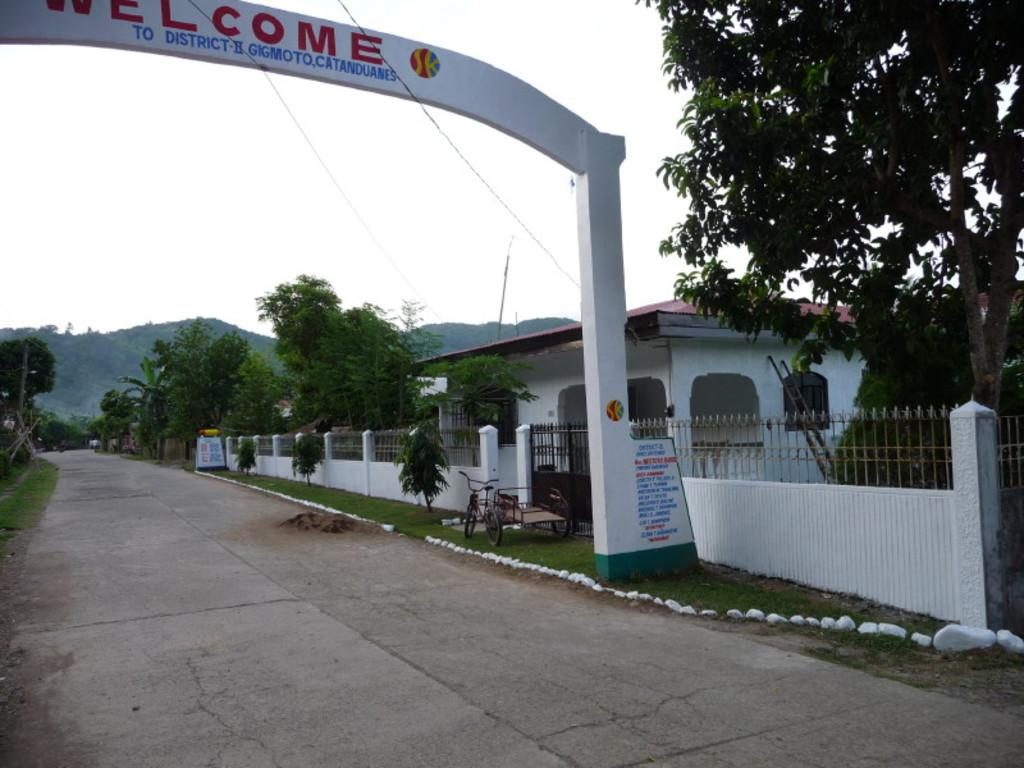What structure is located on the left side of the image? There is an arch on the left side of the image. What is the main feature of the image? The main feature of the image is a road. How is the road positioned in the image? The road appears to be going downward. What is located on the right side of the image? There is a house on the right side of the image. What type of vegetation is present in the image? There are trees in the image. How does the goose contribute to the wealth of the people in the image? There is no goose present in the image, so it cannot contribute to anyone's wealth. What type of amusement is available for the people in the image? The image does not depict any specific amusement activities or facilities. 